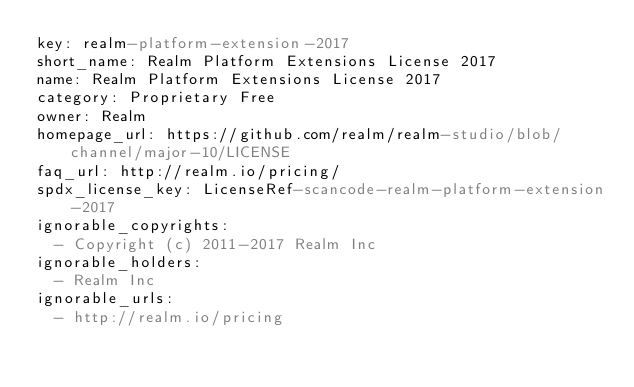<code> <loc_0><loc_0><loc_500><loc_500><_YAML_>key: realm-platform-extension-2017
short_name: Realm Platform Extensions License 2017
name: Realm Platform Extensions License 2017
category: Proprietary Free
owner: Realm
homepage_url: https://github.com/realm/realm-studio/blob/channel/major-10/LICENSE
faq_url: http://realm.io/pricing/
spdx_license_key: LicenseRef-scancode-realm-platform-extension-2017
ignorable_copyrights:
  - Copyright (c) 2011-2017 Realm Inc
ignorable_holders:
  - Realm Inc
ignorable_urls:
  - http://realm.io/pricing

</code> 